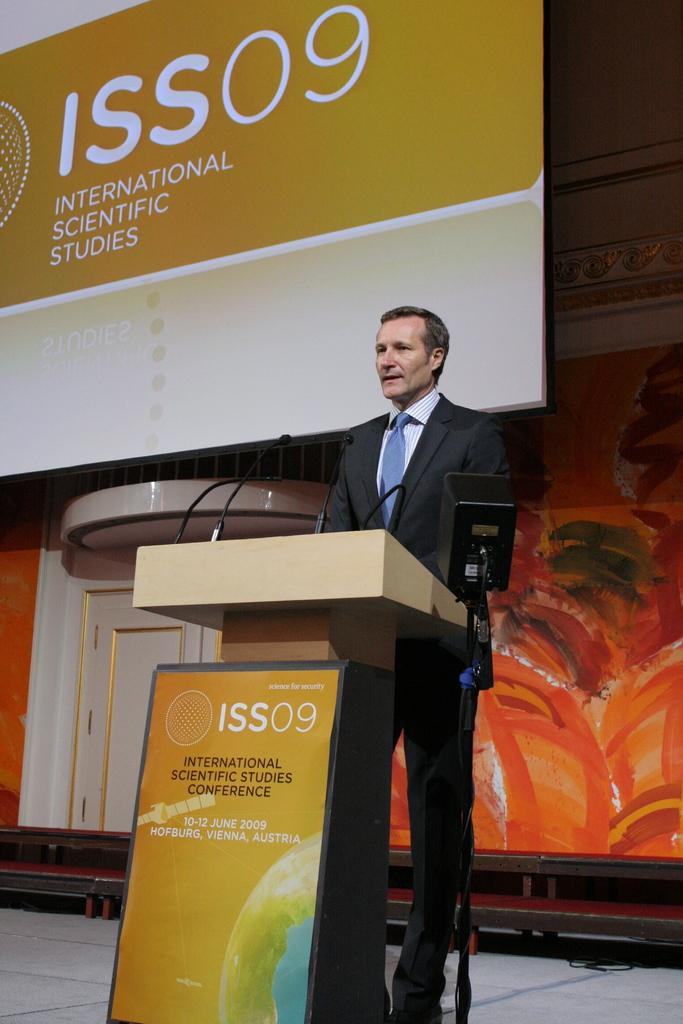Who is present in the image? There is a man in the image. What is the man wearing? The man is wearing a blazer and a tie. What is in front of the man? There are mice and a podium in front of the man. What can be seen in the background of the image? There is a banner, a wall, and some objects in the background of the image. What type of tax is being discussed by the man in the image? There is no indication in the image that the man is discussing any type of tax. What color is the man's underwear in the image? We cannot determine the color of the man's underwear from the image, as it is not visible. 